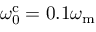<formula> <loc_0><loc_0><loc_500><loc_500>\omega _ { 0 } ^ { c } = 0 . 1 \omega _ { m }</formula> 